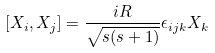Convert formula to latex. <formula><loc_0><loc_0><loc_500><loc_500>[ X _ { i } , X _ { j } ] = \frac { i R } { \sqrt { s ( s + 1 ) } } \epsilon _ { i j k } X _ { k }</formula> 